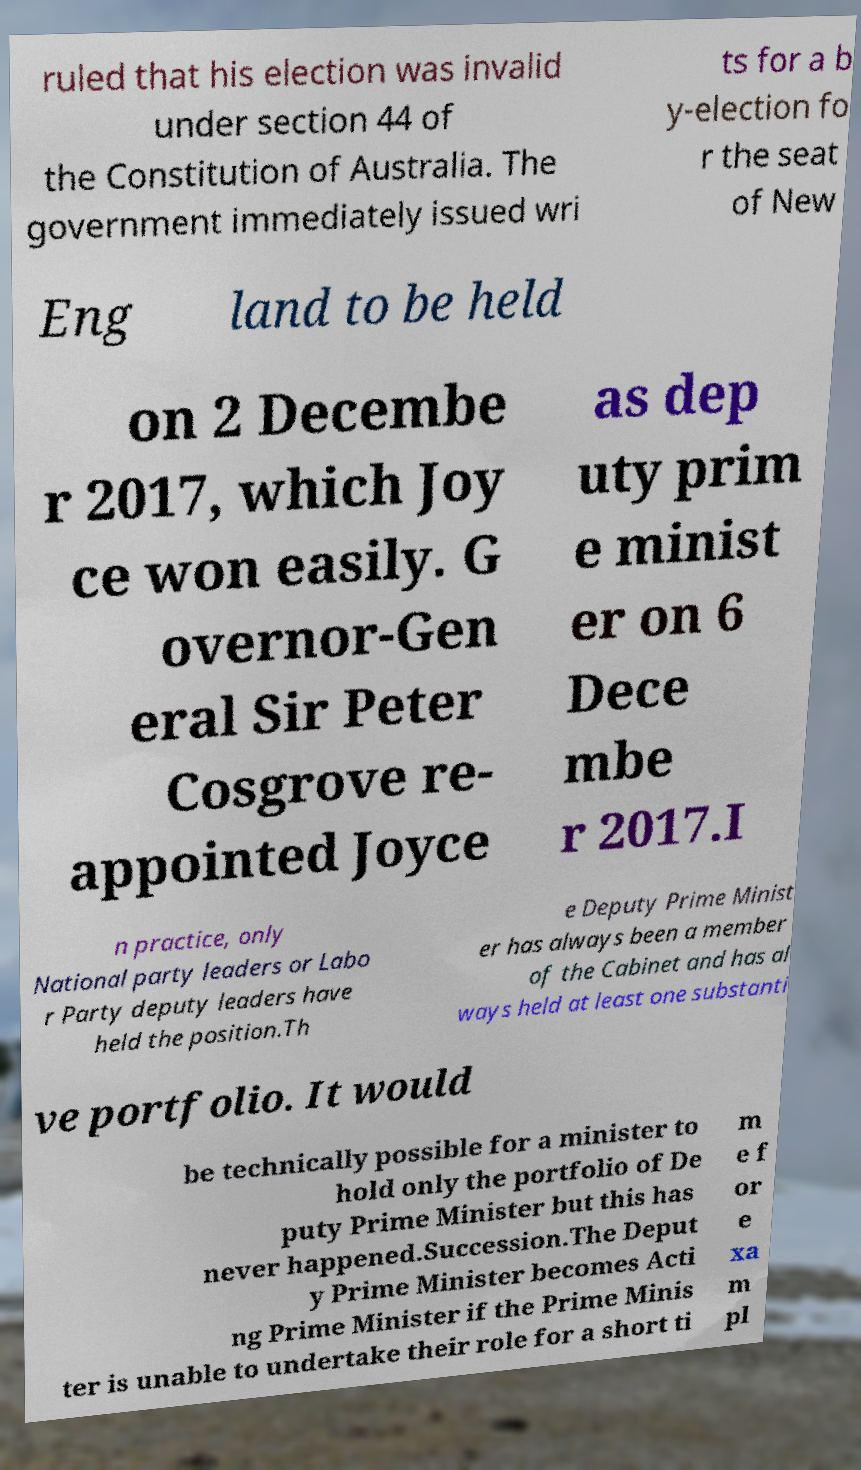Please read and relay the text visible in this image. What does it say? ruled that his election was invalid under section 44 of the Constitution of Australia. The government immediately issued wri ts for a b y-election fo r the seat of New Eng land to be held on 2 Decembe r 2017, which Joy ce won easily. G overnor-Gen eral Sir Peter Cosgrove re- appointed Joyce as dep uty prim e minist er on 6 Dece mbe r 2017.I n practice, only National party leaders or Labo r Party deputy leaders have held the position.Th e Deputy Prime Minist er has always been a member of the Cabinet and has al ways held at least one substanti ve portfolio. It would be technically possible for a minister to hold only the portfolio of De puty Prime Minister but this has never happened.Succession.The Deput y Prime Minister becomes Acti ng Prime Minister if the Prime Minis ter is unable to undertake their role for a short ti m e f or e xa m pl 